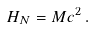Convert formula to latex. <formula><loc_0><loc_0><loc_500><loc_500>H _ { N } = M c ^ { 2 } \, .</formula> 